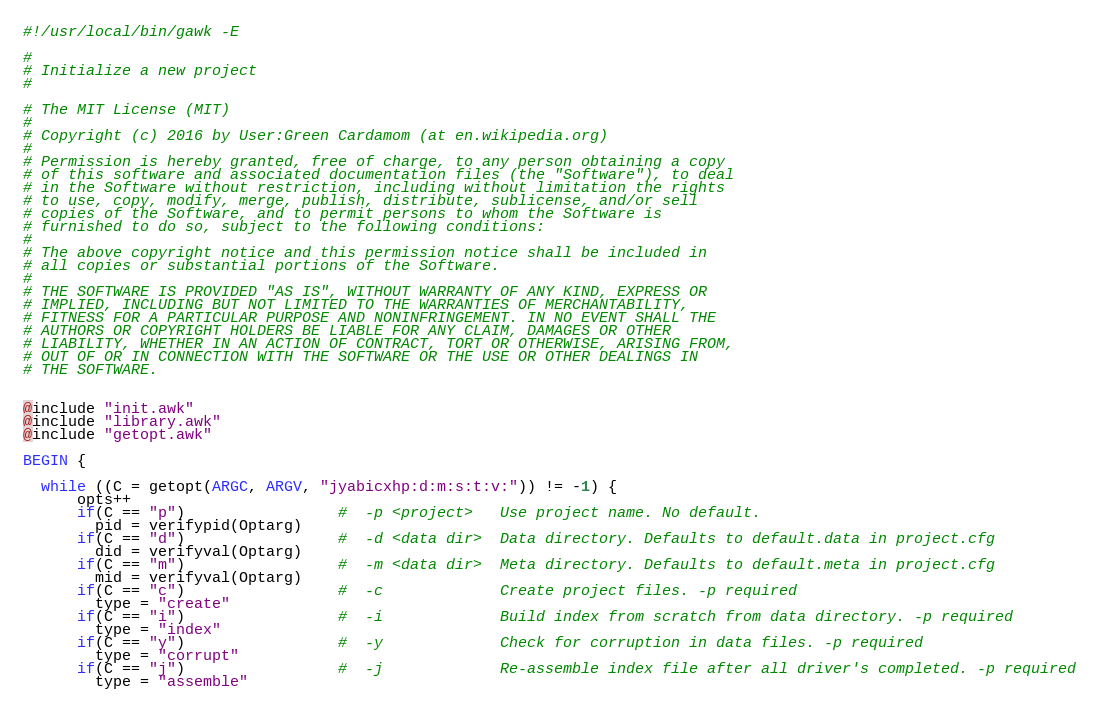<code> <loc_0><loc_0><loc_500><loc_500><_Awk_>#!/usr/local/bin/gawk -E   

#
# Initialize a new project
#

# The MIT License (MIT)
#
# Copyright (c) 2016 by User:Green Cardamom (at en.wikipedia.org)
#
# Permission is hereby granted, free of charge, to any person obtaining a copy
# of this software and associated documentation files (the "Software"), to deal
# in the Software without restriction, including without limitation the rights
# to use, copy, modify, merge, publish, distribute, sublicense, and/or sell
# copies of the Software, and to permit persons to whom the Software is
# furnished to do so, subject to the following conditions:
#
# The above copyright notice and this permission notice shall be included in
# all copies or substantial portions of the Software.
#
# THE SOFTWARE IS PROVIDED "AS IS", WITHOUT WARRANTY OF ANY KIND, EXPRESS OR
# IMPLIED, INCLUDING BUT NOT LIMITED TO THE WARRANTIES OF MERCHANTABILITY,
# FITNESS FOR A PARTICULAR PURPOSE AND NONINFRINGEMENT. IN NO EVENT SHALL THE
# AUTHORS OR COPYRIGHT HOLDERS BE LIABLE FOR ANY CLAIM, DAMAGES OR OTHER
# LIABILITY, WHETHER IN AN ACTION OF CONTRACT, TORT OR OTHERWISE, ARISING FROM,
# OUT OF OR IN CONNECTION WITH THE SOFTWARE OR THE USE OR OTHER DEALINGS IN
# THE SOFTWARE.


@include "init.awk"
@include "library.awk"
@include "getopt.awk"

BEGIN {

  while ((C = getopt(ARGC, ARGV, "jyabicxhp:d:m:s:t:v:")) != -1) { 
      opts++
      if(C == "p")                 #  -p <project>   Use project name. No default.
        pid = verifypid(Optarg)
      if(C == "d")                 #  -d <data dir>  Data directory. Defaults to default.data in project.cfg
        did = verifyval(Optarg)
      if(C == "m")                 #  -m <data dir>  Meta directory. Defaults to default.meta in project.cfg
        mid = verifyval(Optarg)
      if(C == "c")                 #  -c             Create project files. -p required
        type = "create"
      if(C == "i")                 #  -i             Build index from scratch from data directory. -p required
        type = "index"
      if(C == "y")                 #  -y             Check for corruption in data files. -p required
        type = "corrupt"
      if(C == "j")                 #  -j             Re-assemble index file after all driver's completed. -p required
        type = "assemble"</code> 